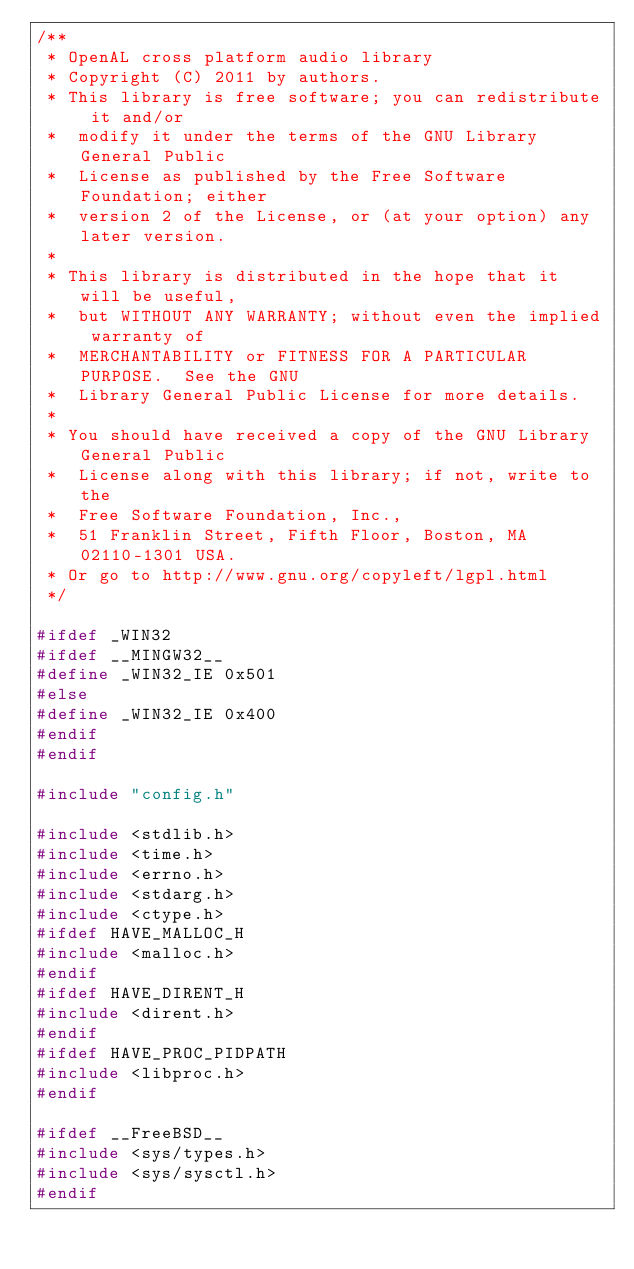Convert code to text. <code><loc_0><loc_0><loc_500><loc_500><_C_>/**
 * OpenAL cross platform audio library
 * Copyright (C) 2011 by authors.
 * This library is free software; you can redistribute it and/or
 *  modify it under the terms of the GNU Library General Public
 *  License as published by the Free Software Foundation; either
 *  version 2 of the License, or (at your option) any later version.
 *
 * This library is distributed in the hope that it will be useful,
 *  but WITHOUT ANY WARRANTY; without even the implied warranty of
 *  MERCHANTABILITY or FITNESS FOR A PARTICULAR PURPOSE.  See the GNU
 *  Library General Public License for more details.
 *
 * You should have received a copy of the GNU Library General Public
 *  License along with this library; if not, write to the
 *  Free Software Foundation, Inc.,
 *  51 Franklin Street, Fifth Floor, Boston, MA 02110-1301 USA.
 * Or go to http://www.gnu.org/copyleft/lgpl.html
 */

#ifdef _WIN32
#ifdef __MINGW32__
#define _WIN32_IE 0x501
#else
#define _WIN32_IE 0x400
#endif
#endif

#include "config.h"

#include <stdlib.h>
#include <time.h>
#include <errno.h>
#include <stdarg.h>
#include <ctype.h>
#ifdef HAVE_MALLOC_H
#include <malloc.h>
#endif
#ifdef HAVE_DIRENT_H
#include <dirent.h>
#endif
#ifdef HAVE_PROC_PIDPATH
#include <libproc.h>
#endif

#ifdef __FreeBSD__
#include <sys/types.h>
#include <sys/sysctl.h>
#endif
</code> 